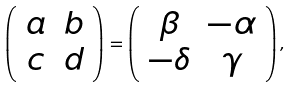Convert formula to latex. <formula><loc_0><loc_0><loc_500><loc_500>\left ( \begin{array} { c c } a & b \\ c & d \end{array} \right ) = \left ( \begin{array} { c c } \beta & - \alpha \\ - \delta & \gamma \end{array} \right ) ,</formula> 